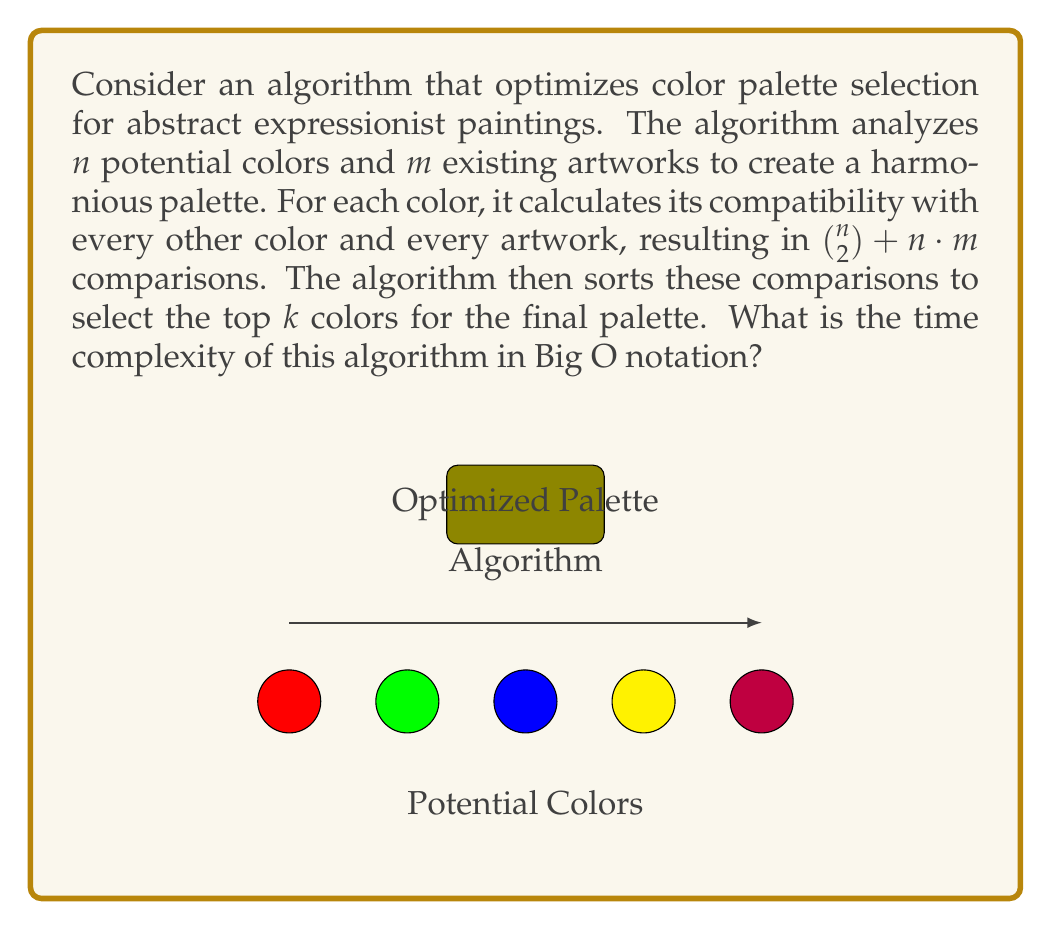Could you help me with this problem? Let's break down the algorithm and analyze its complexity step by step:

1. Color comparisons:
   - The algorithm compares each color with every other color.
   - This results in $\binom{n}{2} = \frac{n(n-1)}{2}$ comparisons.
   - Time complexity: $O(n^2)$

2. Artwork compatibility:
   - Each color is compared with each artwork.
   - This results in $n \cdot m$ comparisons.
   - Time complexity: $O(nm)$

3. Total comparisons:
   - The total number of comparisons is $\binom{n}{2} + n \cdot m$
   - Time complexity: $O(n^2 + nm)$

4. Sorting comparisons:
   - The algorithm sorts all comparisons to select the top $k$ colors.
   - The number of items to sort is $O(n^2 + nm)$
   - Using an efficient sorting algorithm like Merge Sort or Quick Sort, the time complexity for sorting is $O((n^2 + nm) \log(n^2 + nm))$

5. Final selection:
   - Selecting the top $k$ colors from the sorted list is $O(k)$, which is dominated by the sorting step.

The overall time complexity is determined by the most significant term, which is the sorting step:

$$O((n^2 + nm) \log(n^2 + nm))$$

We can simplify this further:
- $\log(n^2 + nm) = \log(n(n + m)) = \log n + \log(n + m)$
- $\log(n + m)$ is bounded by $\log n + \log m$

Therefore, the final time complexity can be expressed as:

$$O((n^2 + nm)(\log n + \log m))$$
Answer: $O((n^2 + nm)(\log n + \log m))$ 